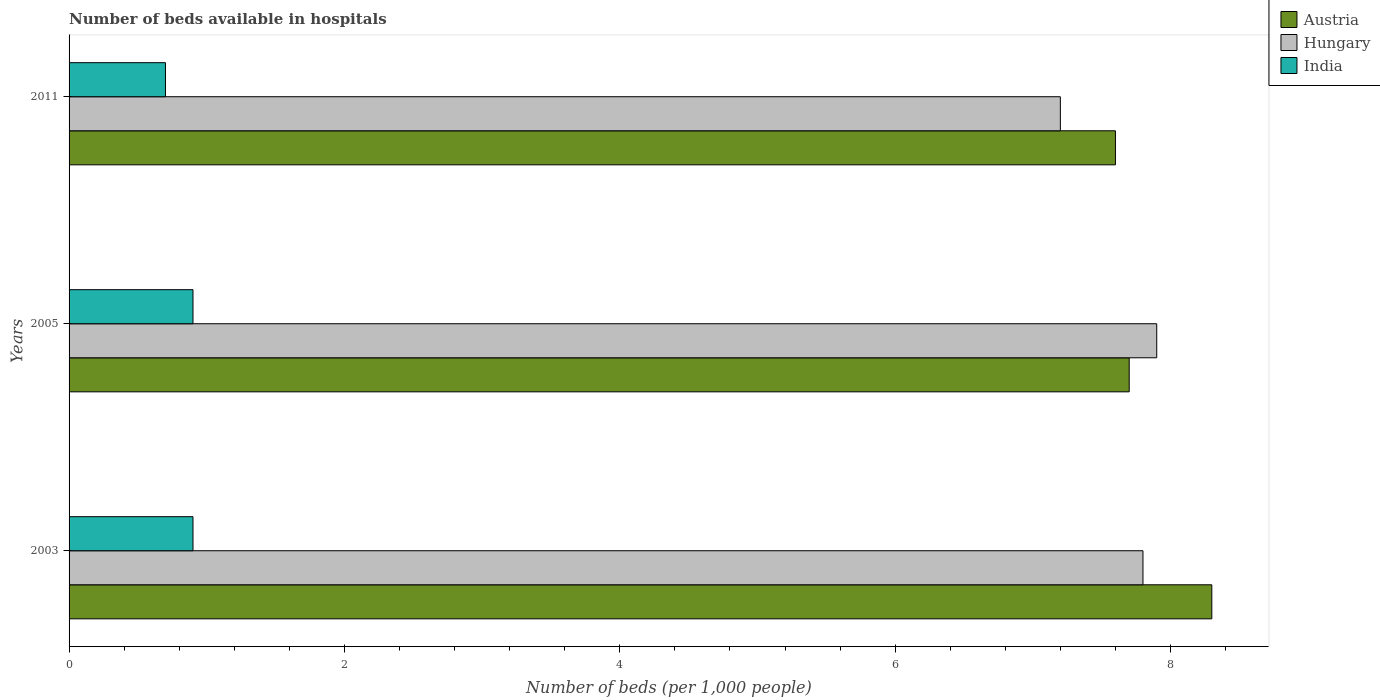Are the number of bars on each tick of the Y-axis equal?
Keep it short and to the point. Yes. What is the label of the 3rd group of bars from the top?
Your response must be concise. 2003. In how many cases, is the number of bars for a given year not equal to the number of legend labels?
Your answer should be very brief. 0. Across all years, what is the maximum number of beds in the hospiatls of in Austria?
Provide a short and direct response. 8.3. In which year was the number of beds in the hospiatls of in India maximum?
Offer a terse response. 2005. In which year was the number of beds in the hospiatls of in India minimum?
Offer a terse response. 2011. What is the total number of beds in the hospiatls of in Austria in the graph?
Keep it short and to the point. 23.6. What is the difference between the number of beds in the hospiatls of in Hungary in 2003 and that in 2011?
Your answer should be very brief. 0.6. What is the average number of beds in the hospiatls of in India per year?
Give a very brief answer. 0.83. In the year 2011, what is the difference between the number of beds in the hospiatls of in Austria and number of beds in the hospiatls of in Hungary?
Ensure brevity in your answer.  0.4. What is the ratio of the number of beds in the hospiatls of in India in 2003 to that in 2011?
Offer a very short reply. 1.29. Is the difference between the number of beds in the hospiatls of in Austria in 2003 and 2005 greater than the difference between the number of beds in the hospiatls of in Hungary in 2003 and 2005?
Make the answer very short. Yes. What is the difference between the highest and the second highest number of beds in the hospiatls of in India?
Provide a short and direct response. 2.3799999970819385e-8. What is the difference between the highest and the lowest number of beds in the hospiatls of in India?
Keep it short and to the point. 0.2. In how many years, is the number of beds in the hospiatls of in Austria greater than the average number of beds in the hospiatls of in Austria taken over all years?
Offer a terse response. 1. What does the 2nd bar from the bottom in 2005 represents?
Your answer should be very brief. Hungary. Is it the case that in every year, the sum of the number of beds in the hospiatls of in Hungary and number of beds in the hospiatls of in Austria is greater than the number of beds in the hospiatls of in India?
Give a very brief answer. Yes. How many bars are there?
Offer a very short reply. 9. Does the graph contain any zero values?
Provide a short and direct response. No. Does the graph contain grids?
Offer a very short reply. No. Where does the legend appear in the graph?
Offer a terse response. Top right. How are the legend labels stacked?
Offer a terse response. Vertical. What is the title of the graph?
Keep it short and to the point. Number of beds available in hospitals. Does "Bhutan" appear as one of the legend labels in the graph?
Offer a terse response. No. What is the label or title of the X-axis?
Provide a succinct answer. Number of beds (per 1,0 people). What is the label or title of the Y-axis?
Your answer should be compact. Years. What is the Number of beds (per 1,000 people) in Austria in 2003?
Make the answer very short. 8.3. What is the Number of beds (per 1,000 people) in Hungary in 2003?
Ensure brevity in your answer.  7.8. What is the Number of beds (per 1,000 people) in India in 2003?
Ensure brevity in your answer.  0.9. What is the Number of beds (per 1,000 people) of Austria in 2005?
Your answer should be compact. 7.7. What is the Number of beds (per 1,000 people) of Hungary in 2005?
Ensure brevity in your answer.  7.9. What is the Number of beds (per 1,000 people) in India in 2005?
Ensure brevity in your answer.  0.9. What is the Number of beds (per 1,000 people) of Hungary in 2011?
Your answer should be compact. 7.2. What is the Number of beds (per 1,000 people) in India in 2011?
Your answer should be very brief. 0.7. Across all years, what is the maximum Number of beds (per 1,000 people) in Austria?
Provide a succinct answer. 8.3. Across all years, what is the maximum Number of beds (per 1,000 people) of Hungary?
Offer a terse response. 7.9. Across all years, what is the maximum Number of beds (per 1,000 people) of India?
Make the answer very short. 0.9. Across all years, what is the minimum Number of beds (per 1,000 people) in Hungary?
Your answer should be compact. 7.2. What is the total Number of beds (per 1,000 people) in Austria in the graph?
Keep it short and to the point. 23.6. What is the total Number of beds (per 1,000 people) of Hungary in the graph?
Your answer should be very brief. 22.9. What is the total Number of beds (per 1,000 people) of India in the graph?
Give a very brief answer. 2.5. What is the difference between the Number of beds (per 1,000 people) in Austria in 2003 and that in 2011?
Provide a short and direct response. 0.7. What is the difference between the Number of beds (per 1,000 people) of Hungary in 2003 and that in 2011?
Offer a terse response. 0.6. What is the difference between the Number of beds (per 1,000 people) in India in 2003 and that in 2011?
Give a very brief answer. 0.2. What is the difference between the Number of beds (per 1,000 people) of India in 2005 and that in 2011?
Offer a very short reply. 0.2. What is the difference between the Number of beds (per 1,000 people) of Austria in 2003 and the Number of beds (per 1,000 people) of India in 2005?
Keep it short and to the point. 7.4. What is the difference between the Number of beds (per 1,000 people) in Austria in 2003 and the Number of beds (per 1,000 people) in India in 2011?
Offer a terse response. 7.6. What is the difference between the Number of beds (per 1,000 people) in Austria in 2005 and the Number of beds (per 1,000 people) in Hungary in 2011?
Your answer should be compact. 0.5. What is the difference between the Number of beds (per 1,000 people) of Austria in 2005 and the Number of beds (per 1,000 people) of India in 2011?
Make the answer very short. 7. What is the difference between the Number of beds (per 1,000 people) of Hungary in 2005 and the Number of beds (per 1,000 people) of India in 2011?
Your answer should be very brief. 7.2. What is the average Number of beds (per 1,000 people) in Austria per year?
Make the answer very short. 7.87. What is the average Number of beds (per 1,000 people) in Hungary per year?
Offer a very short reply. 7.63. In the year 2003, what is the difference between the Number of beds (per 1,000 people) in Austria and Number of beds (per 1,000 people) in Hungary?
Offer a very short reply. 0.5. In the year 2003, what is the difference between the Number of beds (per 1,000 people) of Austria and Number of beds (per 1,000 people) of India?
Give a very brief answer. 7.4. In the year 2003, what is the difference between the Number of beds (per 1,000 people) of Hungary and Number of beds (per 1,000 people) of India?
Your response must be concise. 6.9. In the year 2011, what is the difference between the Number of beds (per 1,000 people) in Austria and Number of beds (per 1,000 people) in India?
Give a very brief answer. 6.9. In the year 2011, what is the difference between the Number of beds (per 1,000 people) in Hungary and Number of beds (per 1,000 people) in India?
Offer a very short reply. 6.5. What is the ratio of the Number of beds (per 1,000 people) of Austria in 2003 to that in 2005?
Provide a short and direct response. 1.08. What is the ratio of the Number of beds (per 1,000 people) of Hungary in 2003 to that in 2005?
Provide a succinct answer. 0.99. What is the ratio of the Number of beds (per 1,000 people) in Austria in 2003 to that in 2011?
Give a very brief answer. 1.09. What is the ratio of the Number of beds (per 1,000 people) in Hungary in 2003 to that in 2011?
Provide a succinct answer. 1.08. What is the ratio of the Number of beds (per 1,000 people) in India in 2003 to that in 2011?
Ensure brevity in your answer.  1.29. What is the ratio of the Number of beds (per 1,000 people) in Austria in 2005 to that in 2011?
Provide a short and direct response. 1.01. What is the ratio of the Number of beds (per 1,000 people) of Hungary in 2005 to that in 2011?
Provide a short and direct response. 1.1. What is the ratio of the Number of beds (per 1,000 people) in India in 2005 to that in 2011?
Provide a short and direct response. 1.29. What is the difference between the highest and the lowest Number of beds (per 1,000 people) in Austria?
Make the answer very short. 0.7. What is the difference between the highest and the lowest Number of beds (per 1,000 people) of India?
Your answer should be very brief. 0.2. 